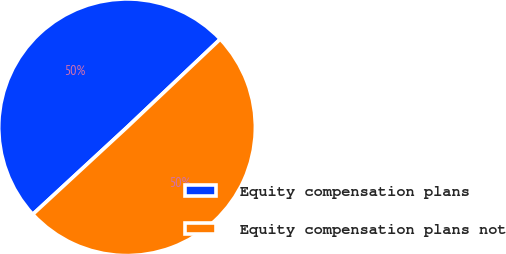Convert chart to OTSL. <chart><loc_0><loc_0><loc_500><loc_500><pie_chart><fcel>Equity compensation plans<fcel>Equity compensation plans not<nl><fcel>49.81%<fcel>50.19%<nl></chart> 